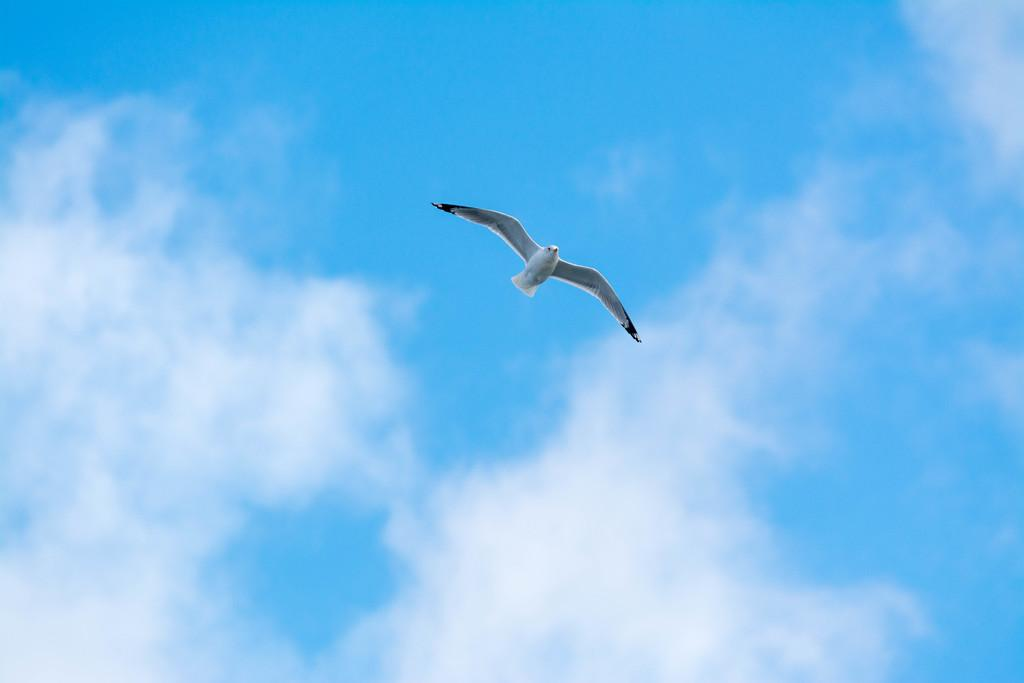What type of animal can be seen in the image? There is a bird in the image. What colors are present on the bird? The bird is white and black in color. What is the bird doing in the image? The bird is flying. How would you describe the sky in the image? The sky is cloudy. How many women are present in the image? There are no women present in the image; it features a bird flying in a cloudy sky. What class of animal is the bird in the image? The bird is a bird, which is a class of animal known as Aves. However, the specific species of bird cannot be determined from the image. 